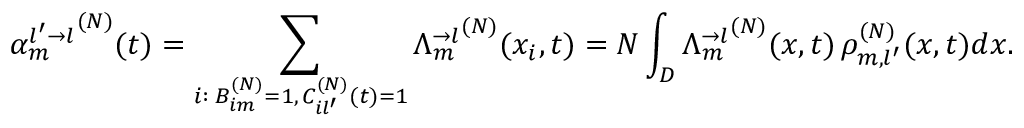Convert formula to latex. <formula><loc_0><loc_0><loc_500><loc_500>{ \alpha _ { m } ^ { l ^ { \prime } \rightarrow l } } ^ { ( N ) } ( t ) = \sum _ { \substack { i \colon \, B _ { i m } ^ { ( N ) } = 1 , \, C _ { i l ^ { \prime } } ^ { ( N ) } ( t ) = 1 } } { \Lambda _ { m } ^ { \rightarrow l } } ^ { ( N ) } ( x _ { i } , t ) = N \int _ { D } { \Lambda _ { m } ^ { \rightarrow l } } ^ { ( N ) } ( x , t ) \, \rho _ { m , l ^ { \prime } } ^ { ( N ) } ( x , t ) d x .</formula> 